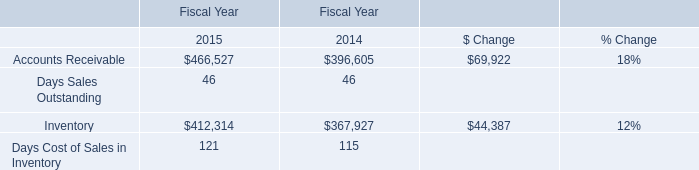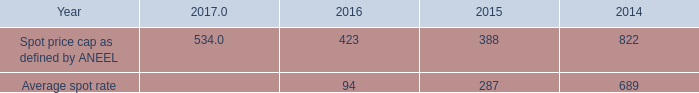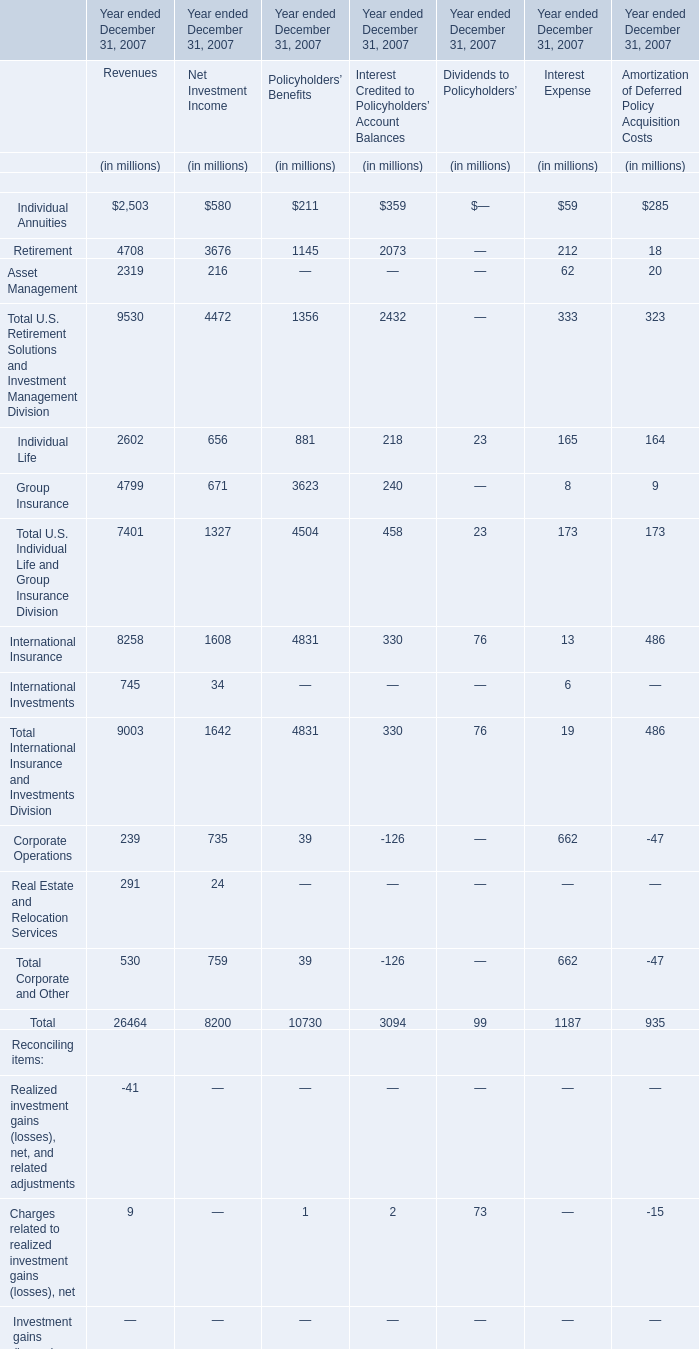What's the sum of all elements that are greater than 4000 for Revenues? (in million) 
Computations: (((4708 + 4799) + 8258) + 7981)
Answer: 25746.0. 